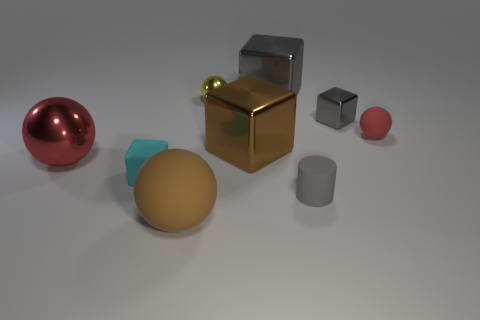Are there fewer tiny rubber things than brown blocks?
Provide a short and direct response. No. Does the small sphere left of the large gray metal thing have the same color as the large matte object?
Provide a short and direct response. No. There is a tiny cube behind the matte ball behind the big red sphere; what number of tiny cyan objects are behind it?
Your answer should be very brief. 0. What number of large red spheres are right of the gray matte thing?
Your answer should be very brief. 0. There is another tiny metallic object that is the same shape as the small cyan object; what is its color?
Make the answer very short. Gray. The large object that is both left of the tiny yellow metallic thing and right of the red metal thing is made of what material?
Your response must be concise. Rubber. Does the yellow sphere that is to the right of the brown matte thing have the same size as the small gray shiny object?
Your answer should be compact. Yes. What material is the gray cylinder?
Provide a succinct answer. Rubber. What is the color of the tiny ball left of the big brown block?
Your answer should be very brief. Yellow. How many tiny objects are either brown metallic cubes or yellow metal spheres?
Offer a terse response. 1. 